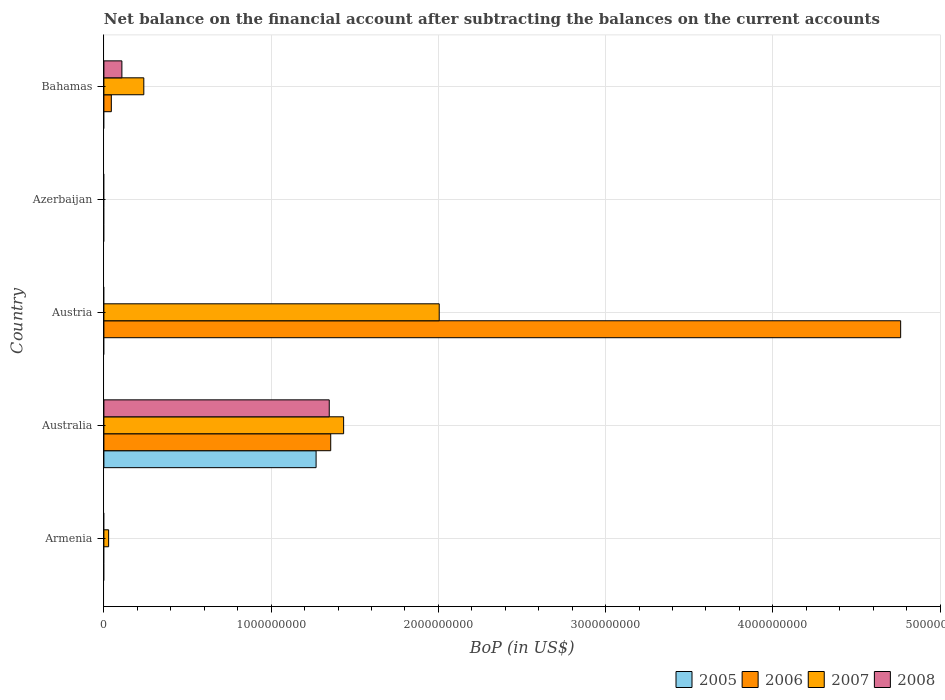How many different coloured bars are there?
Give a very brief answer. 4. Are the number of bars per tick equal to the number of legend labels?
Your answer should be compact. No. Are the number of bars on each tick of the Y-axis equal?
Give a very brief answer. No. How many bars are there on the 4th tick from the bottom?
Provide a succinct answer. 0. In how many cases, is the number of bars for a given country not equal to the number of legend labels?
Keep it short and to the point. 4. What is the Balance of Payments in 2008 in Bahamas?
Provide a short and direct response. 1.08e+08. Across all countries, what is the maximum Balance of Payments in 2006?
Provide a short and direct response. 4.76e+09. Across all countries, what is the minimum Balance of Payments in 2008?
Ensure brevity in your answer.  0. What is the total Balance of Payments in 2007 in the graph?
Provide a short and direct response. 3.71e+09. What is the difference between the Balance of Payments in 2006 in Australia and that in Austria?
Provide a short and direct response. -3.41e+09. What is the difference between the Balance of Payments in 2006 in Australia and the Balance of Payments in 2007 in Armenia?
Make the answer very short. 1.33e+09. What is the average Balance of Payments in 2008 per country?
Your answer should be very brief. 2.91e+08. What is the difference between the Balance of Payments in 2007 and Balance of Payments in 2006 in Australia?
Provide a succinct answer. 7.72e+07. In how many countries, is the Balance of Payments in 2005 greater than 1400000000 US$?
Your answer should be compact. 0. What is the ratio of the Balance of Payments in 2007 in Australia to that in Austria?
Provide a short and direct response. 0.71. Is the difference between the Balance of Payments in 2007 in Austria and Bahamas greater than the difference between the Balance of Payments in 2006 in Austria and Bahamas?
Provide a succinct answer. No. What is the difference between the highest and the second highest Balance of Payments in 2007?
Keep it short and to the point. 5.72e+08. What is the difference between the highest and the lowest Balance of Payments in 2007?
Offer a terse response. 2.00e+09. Are the values on the major ticks of X-axis written in scientific E-notation?
Ensure brevity in your answer.  No. Where does the legend appear in the graph?
Provide a short and direct response. Bottom right. How many legend labels are there?
Keep it short and to the point. 4. How are the legend labels stacked?
Your answer should be compact. Horizontal. What is the title of the graph?
Keep it short and to the point. Net balance on the financial account after subtracting the balances on the current accounts. What is the label or title of the X-axis?
Your answer should be compact. BoP (in US$). What is the BoP (in US$) in 2007 in Armenia?
Give a very brief answer. 2.83e+07. What is the BoP (in US$) of 2008 in Armenia?
Your answer should be very brief. 0. What is the BoP (in US$) of 2005 in Australia?
Ensure brevity in your answer.  1.27e+09. What is the BoP (in US$) in 2006 in Australia?
Offer a very short reply. 1.36e+09. What is the BoP (in US$) of 2007 in Australia?
Ensure brevity in your answer.  1.43e+09. What is the BoP (in US$) of 2008 in Australia?
Provide a succinct answer. 1.35e+09. What is the BoP (in US$) of 2005 in Austria?
Your answer should be compact. 0. What is the BoP (in US$) in 2006 in Austria?
Keep it short and to the point. 4.76e+09. What is the BoP (in US$) in 2007 in Austria?
Ensure brevity in your answer.  2.00e+09. What is the BoP (in US$) in 2005 in Azerbaijan?
Give a very brief answer. 0. What is the BoP (in US$) of 2006 in Azerbaijan?
Provide a short and direct response. 0. What is the BoP (in US$) of 2007 in Azerbaijan?
Offer a very short reply. 0. What is the BoP (in US$) of 2006 in Bahamas?
Offer a very short reply. 4.45e+07. What is the BoP (in US$) in 2007 in Bahamas?
Provide a short and direct response. 2.39e+08. What is the BoP (in US$) of 2008 in Bahamas?
Make the answer very short. 1.08e+08. Across all countries, what is the maximum BoP (in US$) of 2005?
Provide a succinct answer. 1.27e+09. Across all countries, what is the maximum BoP (in US$) in 2006?
Provide a short and direct response. 4.76e+09. Across all countries, what is the maximum BoP (in US$) of 2007?
Provide a short and direct response. 2.00e+09. Across all countries, what is the maximum BoP (in US$) of 2008?
Your response must be concise. 1.35e+09. Across all countries, what is the minimum BoP (in US$) of 2008?
Ensure brevity in your answer.  0. What is the total BoP (in US$) of 2005 in the graph?
Offer a very short reply. 1.27e+09. What is the total BoP (in US$) of 2006 in the graph?
Provide a succinct answer. 6.16e+09. What is the total BoP (in US$) in 2007 in the graph?
Your response must be concise. 3.71e+09. What is the total BoP (in US$) of 2008 in the graph?
Make the answer very short. 1.46e+09. What is the difference between the BoP (in US$) in 2007 in Armenia and that in Australia?
Offer a terse response. -1.41e+09. What is the difference between the BoP (in US$) in 2007 in Armenia and that in Austria?
Offer a very short reply. -1.98e+09. What is the difference between the BoP (in US$) in 2007 in Armenia and that in Bahamas?
Offer a very short reply. -2.10e+08. What is the difference between the BoP (in US$) in 2006 in Australia and that in Austria?
Provide a succinct answer. -3.41e+09. What is the difference between the BoP (in US$) in 2007 in Australia and that in Austria?
Ensure brevity in your answer.  -5.72e+08. What is the difference between the BoP (in US$) in 2006 in Australia and that in Bahamas?
Your answer should be very brief. 1.31e+09. What is the difference between the BoP (in US$) in 2007 in Australia and that in Bahamas?
Offer a very short reply. 1.19e+09. What is the difference between the BoP (in US$) in 2008 in Australia and that in Bahamas?
Offer a terse response. 1.24e+09. What is the difference between the BoP (in US$) in 2006 in Austria and that in Bahamas?
Provide a succinct answer. 4.72e+09. What is the difference between the BoP (in US$) in 2007 in Austria and that in Bahamas?
Offer a very short reply. 1.77e+09. What is the difference between the BoP (in US$) in 2007 in Armenia and the BoP (in US$) in 2008 in Australia?
Make the answer very short. -1.32e+09. What is the difference between the BoP (in US$) of 2007 in Armenia and the BoP (in US$) of 2008 in Bahamas?
Give a very brief answer. -7.93e+07. What is the difference between the BoP (in US$) in 2005 in Australia and the BoP (in US$) in 2006 in Austria?
Make the answer very short. -3.50e+09. What is the difference between the BoP (in US$) of 2005 in Australia and the BoP (in US$) of 2007 in Austria?
Ensure brevity in your answer.  -7.36e+08. What is the difference between the BoP (in US$) of 2006 in Australia and the BoP (in US$) of 2007 in Austria?
Make the answer very short. -6.49e+08. What is the difference between the BoP (in US$) of 2005 in Australia and the BoP (in US$) of 2006 in Bahamas?
Keep it short and to the point. 1.22e+09. What is the difference between the BoP (in US$) in 2005 in Australia and the BoP (in US$) in 2007 in Bahamas?
Provide a short and direct response. 1.03e+09. What is the difference between the BoP (in US$) in 2005 in Australia and the BoP (in US$) in 2008 in Bahamas?
Offer a terse response. 1.16e+09. What is the difference between the BoP (in US$) in 2006 in Australia and the BoP (in US$) in 2007 in Bahamas?
Offer a terse response. 1.12e+09. What is the difference between the BoP (in US$) of 2006 in Australia and the BoP (in US$) of 2008 in Bahamas?
Keep it short and to the point. 1.25e+09. What is the difference between the BoP (in US$) of 2007 in Australia and the BoP (in US$) of 2008 in Bahamas?
Ensure brevity in your answer.  1.33e+09. What is the difference between the BoP (in US$) of 2006 in Austria and the BoP (in US$) of 2007 in Bahamas?
Give a very brief answer. 4.53e+09. What is the difference between the BoP (in US$) of 2006 in Austria and the BoP (in US$) of 2008 in Bahamas?
Offer a very short reply. 4.66e+09. What is the difference between the BoP (in US$) of 2007 in Austria and the BoP (in US$) of 2008 in Bahamas?
Your response must be concise. 1.90e+09. What is the average BoP (in US$) of 2005 per country?
Your answer should be very brief. 2.54e+08. What is the average BoP (in US$) in 2006 per country?
Provide a short and direct response. 1.23e+09. What is the average BoP (in US$) of 2007 per country?
Provide a short and direct response. 7.41e+08. What is the average BoP (in US$) of 2008 per country?
Offer a very short reply. 2.91e+08. What is the difference between the BoP (in US$) in 2005 and BoP (in US$) in 2006 in Australia?
Your response must be concise. -8.74e+07. What is the difference between the BoP (in US$) in 2005 and BoP (in US$) in 2007 in Australia?
Your response must be concise. -1.65e+08. What is the difference between the BoP (in US$) of 2005 and BoP (in US$) of 2008 in Australia?
Ensure brevity in your answer.  -7.86e+07. What is the difference between the BoP (in US$) in 2006 and BoP (in US$) in 2007 in Australia?
Your answer should be very brief. -7.72e+07. What is the difference between the BoP (in US$) of 2006 and BoP (in US$) of 2008 in Australia?
Your answer should be very brief. 8.75e+06. What is the difference between the BoP (in US$) in 2007 and BoP (in US$) in 2008 in Australia?
Your answer should be very brief. 8.59e+07. What is the difference between the BoP (in US$) in 2006 and BoP (in US$) in 2007 in Austria?
Provide a succinct answer. 2.76e+09. What is the difference between the BoP (in US$) in 2006 and BoP (in US$) in 2007 in Bahamas?
Ensure brevity in your answer.  -1.94e+08. What is the difference between the BoP (in US$) in 2006 and BoP (in US$) in 2008 in Bahamas?
Ensure brevity in your answer.  -6.31e+07. What is the difference between the BoP (in US$) of 2007 and BoP (in US$) of 2008 in Bahamas?
Your response must be concise. 1.31e+08. What is the ratio of the BoP (in US$) of 2007 in Armenia to that in Australia?
Your answer should be very brief. 0.02. What is the ratio of the BoP (in US$) in 2007 in Armenia to that in Austria?
Your response must be concise. 0.01. What is the ratio of the BoP (in US$) in 2007 in Armenia to that in Bahamas?
Offer a very short reply. 0.12. What is the ratio of the BoP (in US$) of 2006 in Australia to that in Austria?
Ensure brevity in your answer.  0.28. What is the ratio of the BoP (in US$) of 2007 in Australia to that in Austria?
Ensure brevity in your answer.  0.71. What is the ratio of the BoP (in US$) in 2006 in Australia to that in Bahamas?
Provide a succinct answer. 30.48. What is the ratio of the BoP (in US$) in 2007 in Australia to that in Bahamas?
Give a very brief answer. 6.01. What is the ratio of the BoP (in US$) of 2008 in Australia to that in Bahamas?
Your answer should be compact. 12.52. What is the ratio of the BoP (in US$) of 2006 in Austria to that in Bahamas?
Your answer should be compact. 107.05. What is the ratio of the BoP (in US$) of 2007 in Austria to that in Bahamas?
Give a very brief answer. 8.4. What is the difference between the highest and the second highest BoP (in US$) of 2006?
Offer a very short reply. 3.41e+09. What is the difference between the highest and the second highest BoP (in US$) of 2007?
Offer a terse response. 5.72e+08. What is the difference between the highest and the lowest BoP (in US$) in 2005?
Give a very brief answer. 1.27e+09. What is the difference between the highest and the lowest BoP (in US$) in 2006?
Make the answer very short. 4.76e+09. What is the difference between the highest and the lowest BoP (in US$) in 2007?
Offer a terse response. 2.00e+09. What is the difference between the highest and the lowest BoP (in US$) of 2008?
Offer a terse response. 1.35e+09. 